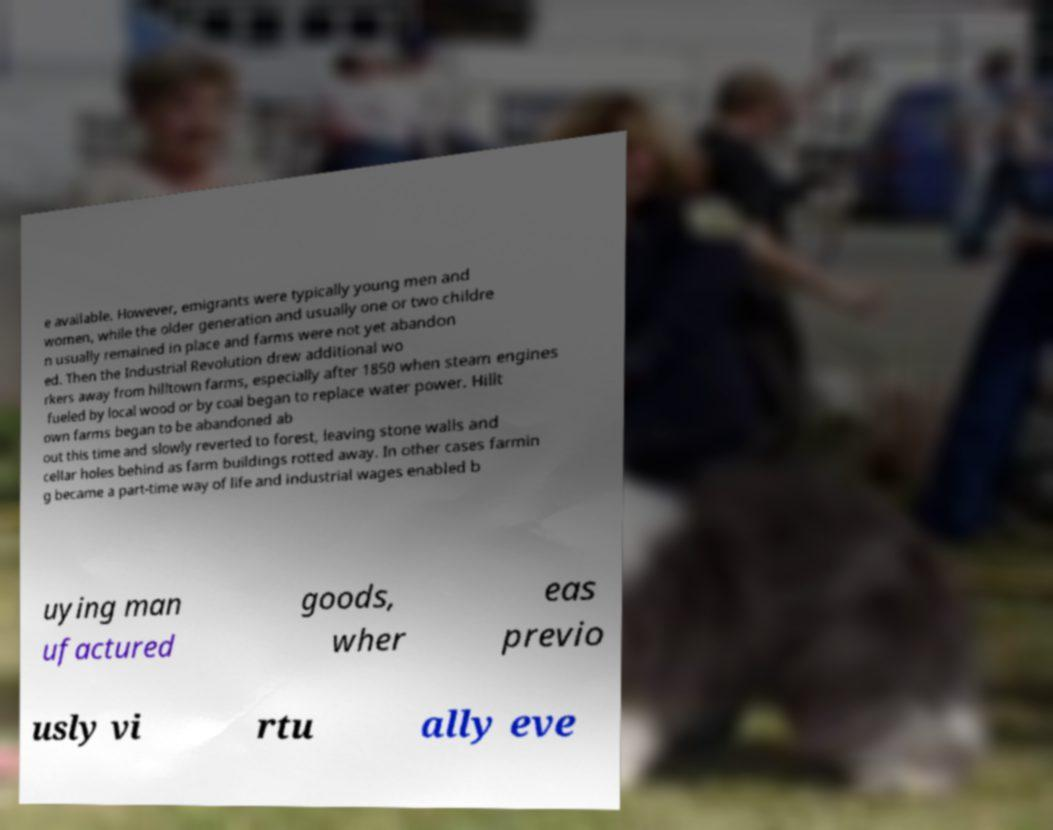Please identify and transcribe the text found in this image. e available. However, emigrants were typically young men and women, while the older generation and usually one or two childre n usually remained in place and farms were not yet abandon ed. Then the Industrial Revolution drew additional wo rkers away from hilltown farms, especially after 1850 when steam engines fueled by local wood or by coal began to replace water power. Hillt own farms began to be abandoned ab out this time and slowly reverted to forest, leaving stone walls and cellar holes behind as farm buildings rotted away. In other cases farmin g became a part-time way of life and industrial wages enabled b uying man ufactured goods, wher eas previo usly vi rtu ally eve 